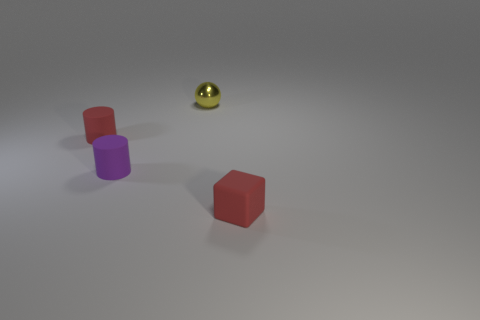Subtract all green balls. Subtract all red cylinders. How many balls are left? 1 Add 1 small purple cylinders. How many objects exist? 5 Subtract all spheres. How many objects are left? 3 Subtract all shiny balls. Subtract all tiny purple rubber objects. How many objects are left? 2 Add 4 tiny balls. How many tiny balls are left? 5 Add 1 small brown rubber cylinders. How many small brown rubber cylinders exist? 1 Subtract 0 gray cylinders. How many objects are left? 4 